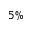<formula> <loc_0><loc_0><loc_500><loc_500>5 \%</formula> 